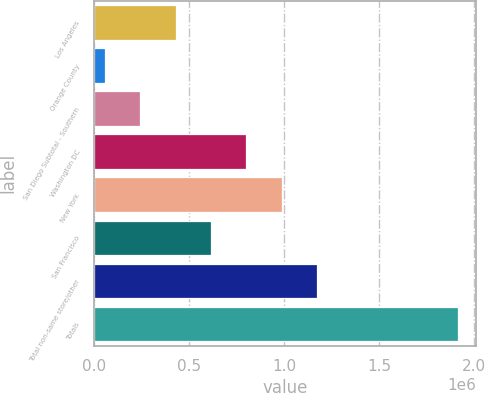Convert chart to OTSL. <chart><loc_0><loc_0><loc_500><loc_500><bar_chart><fcel>Los Angeles<fcel>Orange County<fcel>San Diego Subtotal - Southern<fcel>Washington DC<fcel>New York<fcel>San Francisco<fcel>Total non-same store/other<fcel>Totals<nl><fcel>428738<fcel>56518<fcel>242628<fcel>800957<fcel>987067<fcel>614847<fcel>1.17318e+06<fcel>1.91762e+06<nl></chart> 